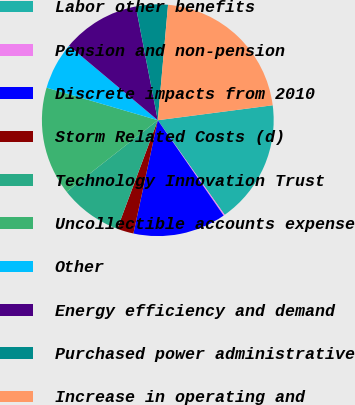Convert chart. <chart><loc_0><loc_0><loc_500><loc_500><pie_chart><fcel>Labor other benefits<fcel>Pension and non-pension<fcel>Discrete impacts from 2010<fcel>Storm Related Costs (d)<fcel>Technology Innovation Trust<fcel>Uncollectible accounts expense<fcel>Other<fcel>Energy efficiency and demand<fcel>Purchased power administrative<fcel>Increase in operating and<nl><fcel>17.26%<fcel>0.18%<fcel>12.99%<fcel>2.31%<fcel>8.72%<fcel>15.12%<fcel>6.58%<fcel>10.85%<fcel>4.45%<fcel>21.53%<nl></chart> 